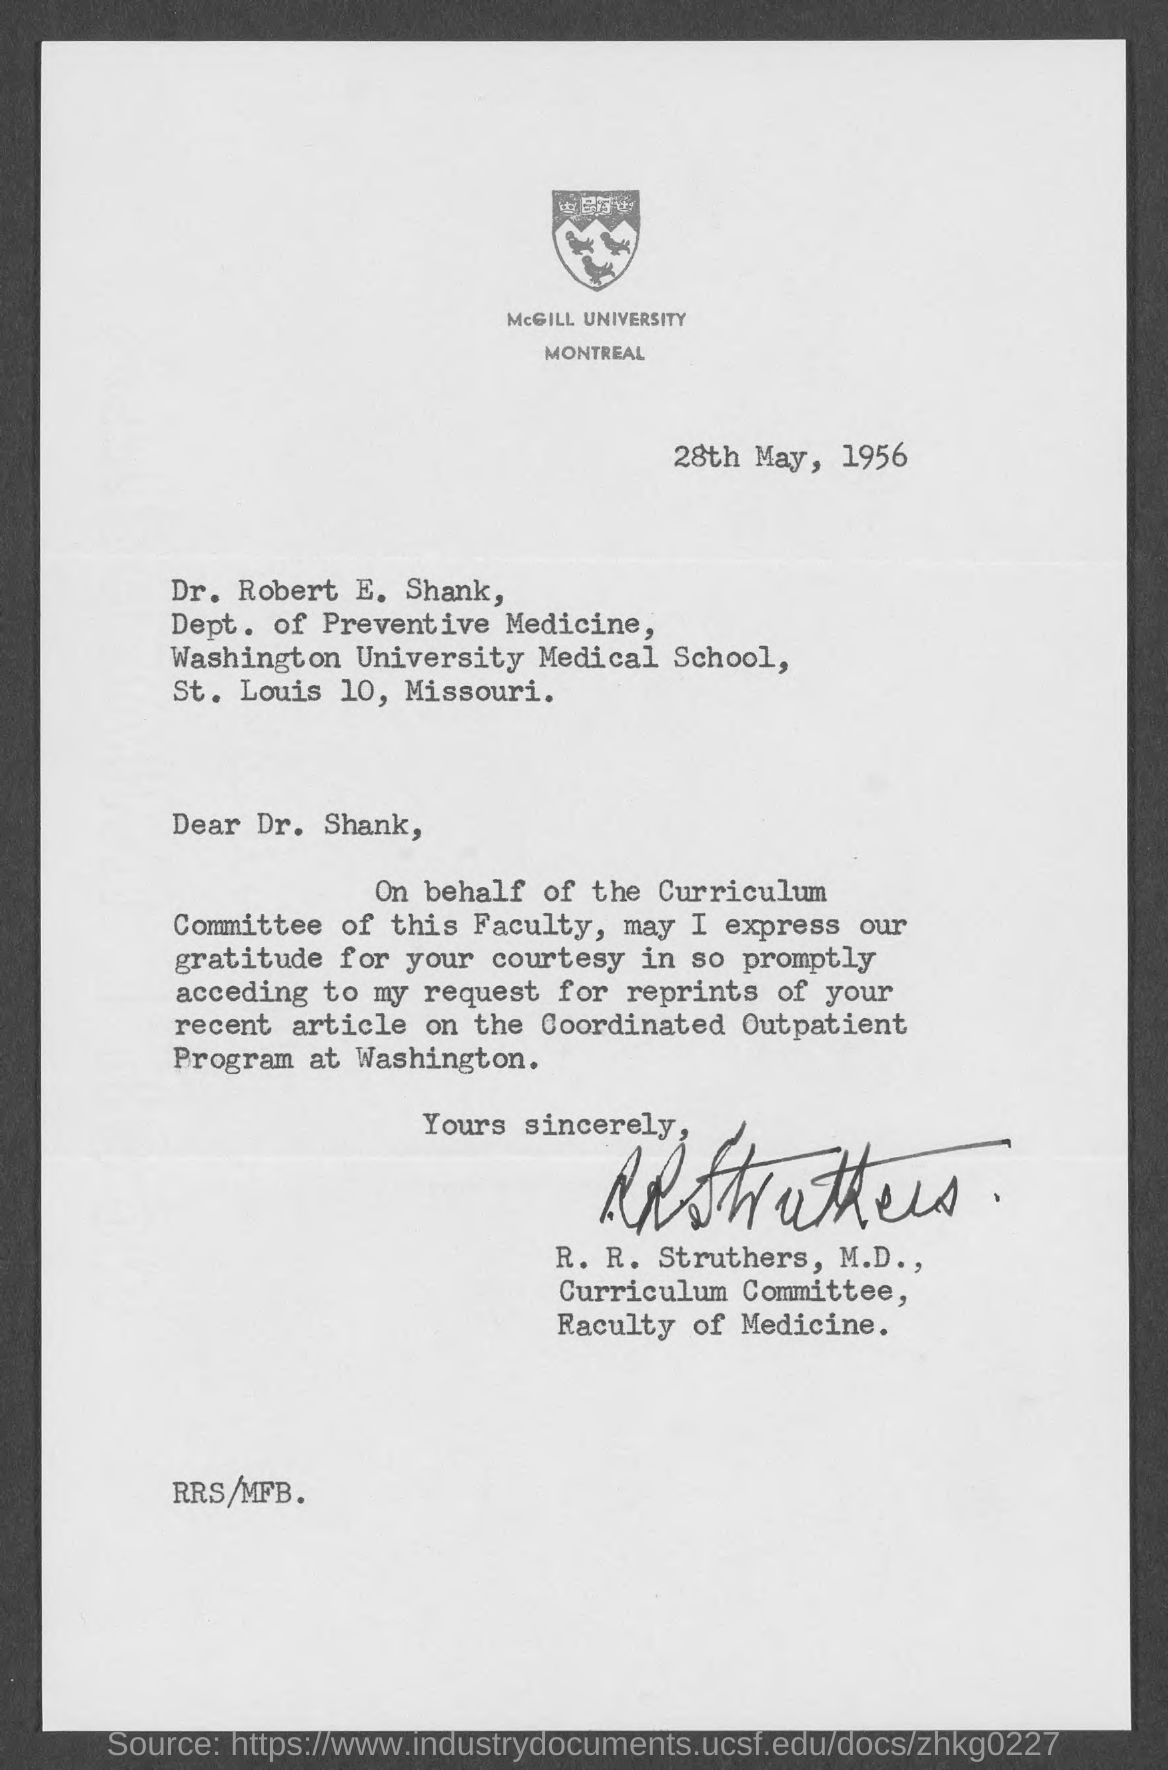Where is the McGill University located?
Your answer should be very brief. MONTREAL. What is the date mentioned in this letter?
Offer a very short reply. 28TH MAY, 1956. 